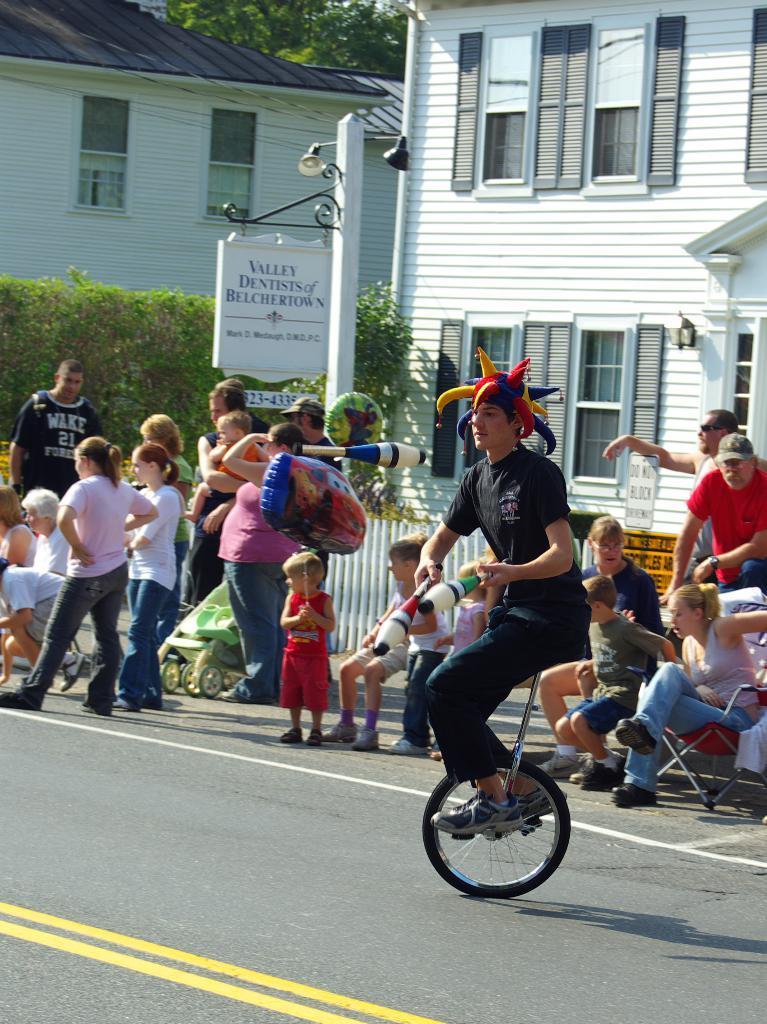How would you summarize this image in a sentence or two? In this image we can see a person sitting on the unicycle, persons standing on the road and some are sitting in the chairs. In the background we can see buildings, street poles, street lights, information boards, creepers, trees and wooden fence. 